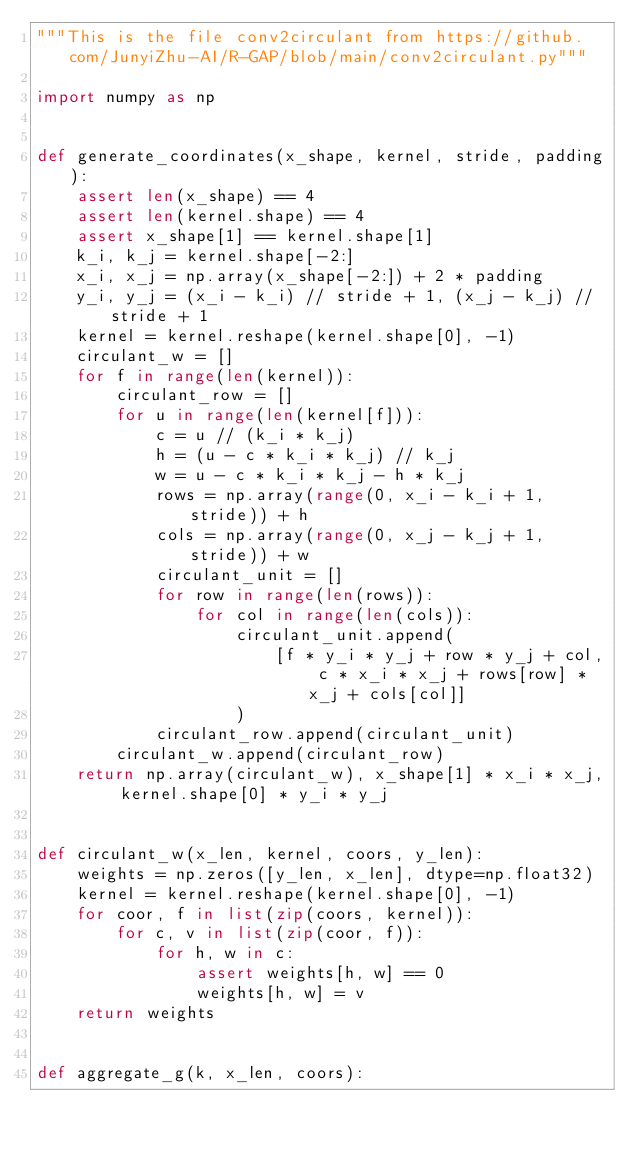<code> <loc_0><loc_0><loc_500><loc_500><_Python_>"""This is the file conv2circulant from https://github.com/JunyiZhu-AI/R-GAP/blob/main/conv2circulant.py"""

import numpy as np


def generate_coordinates(x_shape, kernel, stride, padding):
    assert len(x_shape) == 4
    assert len(kernel.shape) == 4
    assert x_shape[1] == kernel.shape[1]
    k_i, k_j = kernel.shape[-2:]
    x_i, x_j = np.array(x_shape[-2:]) + 2 * padding
    y_i, y_j = (x_i - k_i) // stride + 1, (x_j - k_j) // stride + 1
    kernel = kernel.reshape(kernel.shape[0], -1)
    circulant_w = []
    for f in range(len(kernel)):
        circulant_row = []
        for u in range(len(kernel[f])):
            c = u // (k_i * k_j)
            h = (u - c * k_i * k_j) // k_j
            w = u - c * k_i * k_j - h * k_j
            rows = np.array(range(0, x_i - k_i + 1, stride)) + h
            cols = np.array(range(0, x_j - k_j + 1, stride)) + w
            circulant_unit = []
            for row in range(len(rows)):
                for col in range(len(cols)):
                    circulant_unit.append(
                        [f * y_i * y_j + row * y_j + col, c * x_i * x_j + rows[row] * x_j + cols[col]]
                    )
            circulant_row.append(circulant_unit)
        circulant_w.append(circulant_row)
    return np.array(circulant_w), x_shape[1] * x_i * x_j, kernel.shape[0] * y_i * y_j


def circulant_w(x_len, kernel, coors, y_len):
    weights = np.zeros([y_len, x_len], dtype=np.float32)
    kernel = kernel.reshape(kernel.shape[0], -1)
    for coor, f in list(zip(coors, kernel)):
        for c, v in list(zip(coor, f)):
            for h, w in c:
                assert weights[h, w] == 0
                weights[h, w] = v
    return weights


def aggregate_g(k, x_len, coors):</code> 